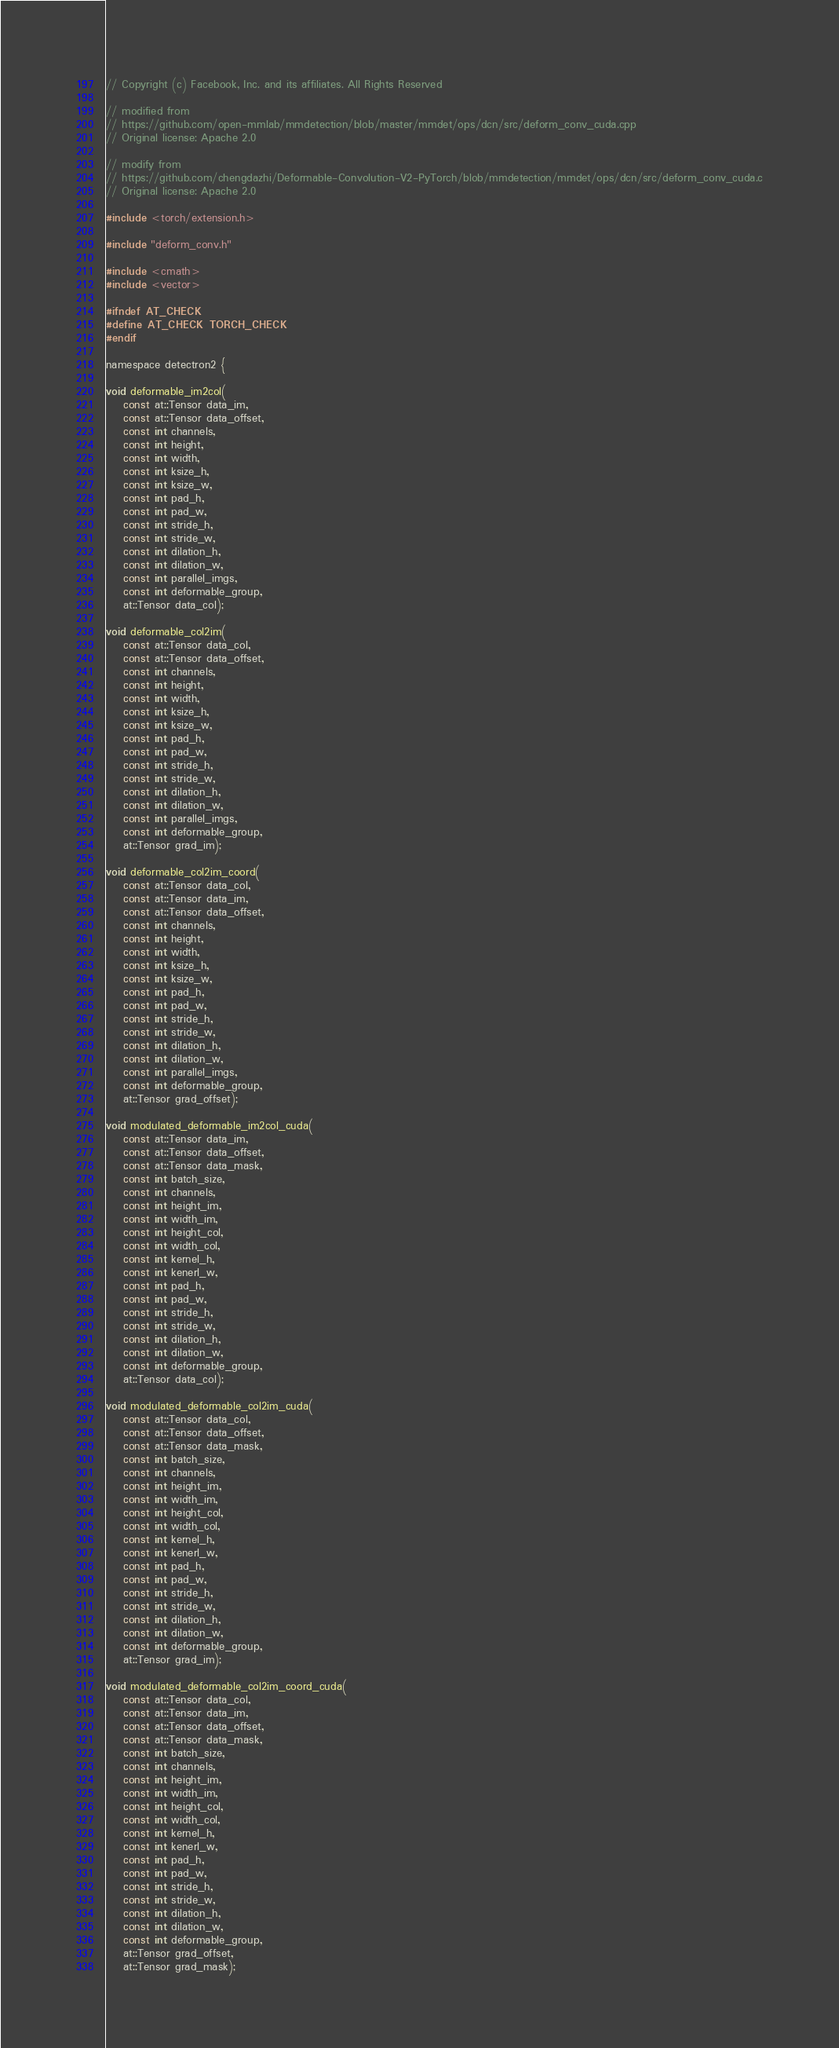Convert code to text. <code><loc_0><loc_0><loc_500><loc_500><_Cuda_>// Copyright (c) Facebook, Inc. and its affiliates. All Rights Reserved

// modified from
// https://github.com/open-mmlab/mmdetection/blob/master/mmdet/ops/dcn/src/deform_conv_cuda.cpp
// Original license: Apache 2.0

// modify from
// https://github.com/chengdazhi/Deformable-Convolution-V2-PyTorch/blob/mmdetection/mmdet/ops/dcn/src/deform_conv_cuda.c
// Original license: Apache 2.0

#include <torch/extension.h>

#include "deform_conv.h"

#include <cmath>
#include <vector>

#ifndef AT_CHECK
#define AT_CHECK TORCH_CHECK 
#endif

namespace detectron2 {

void deformable_im2col(
    const at::Tensor data_im,
    const at::Tensor data_offset,
    const int channels,
    const int height,
    const int width,
    const int ksize_h,
    const int ksize_w,
    const int pad_h,
    const int pad_w,
    const int stride_h,
    const int stride_w,
    const int dilation_h,
    const int dilation_w,
    const int parallel_imgs,
    const int deformable_group,
    at::Tensor data_col);

void deformable_col2im(
    const at::Tensor data_col,
    const at::Tensor data_offset,
    const int channels,
    const int height,
    const int width,
    const int ksize_h,
    const int ksize_w,
    const int pad_h,
    const int pad_w,
    const int stride_h,
    const int stride_w,
    const int dilation_h,
    const int dilation_w,
    const int parallel_imgs,
    const int deformable_group,
    at::Tensor grad_im);

void deformable_col2im_coord(
    const at::Tensor data_col,
    const at::Tensor data_im,
    const at::Tensor data_offset,
    const int channels,
    const int height,
    const int width,
    const int ksize_h,
    const int ksize_w,
    const int pad_h,
    const int pad_w,
    const int stride_h,
    const int stride_w,
    const int dilation_h,
    const int dilation_w,
    const int parallel_imgs,
    const int deformable_group,
    at::Tensor grad_offset);

void modulated_deformable_im2col_cuda(
    const at::Tensor data_im,
    const at::Tensor data_offset,
    const at::Tensor data_mask,
    const int batch_size,
    const int channels,
    const int height_im,
    const int width_im,
    const int height_col,
    const int width_col,
    const int kernel_h,
    const int kenerl_w,
    const int pad_h,
    const int pad_w,
    const int stride_h,
    const int stride_w,
    const int dilation_h,
    const int dilation_w,
    const int deformable_group,
    at::Tensor data_col);

void modulated_deformable_col2im_cuda(
    const at::Tensor data_col,
    const at::Tensor data_offset,
    const at::Tensor data_mask,
    const int batch_size,
    const int channels,
    const int height_im,
    const int width_im,
    const int height_col,
    const int width_col,
    const int kernel_h,
    const int kenerl_w,
    const int pad_h,
    const int pad_w,
    const int stride_h,
    const int stride_w,
    const int dilation_h,
    const int dilation_w,
    const int deformable_group,
    at::Tensor grad_im);

void modulated_deformable_col2im_coord_cuda(
    const at::Tensor data_col,
    const at::Tensor data_im,
    const at::Tensor data_offset,
    const at::Tensor data_mask,
    const int batch_size,
    const int channels,
    const int height_im,
    const int width_im,
    const int height_col,
    const int width_col,
    const int kernel_h,
    const int kenerl_w,
    const int pad_h,
    const int pad_w,
    const int stride_h,
    const int stride_w,
    const int dilation_h,
    const int dilation_w,
    const int deformable_group,
    at::Tensor grad_offset,
    at::Tensor grad_mask);
</code> 